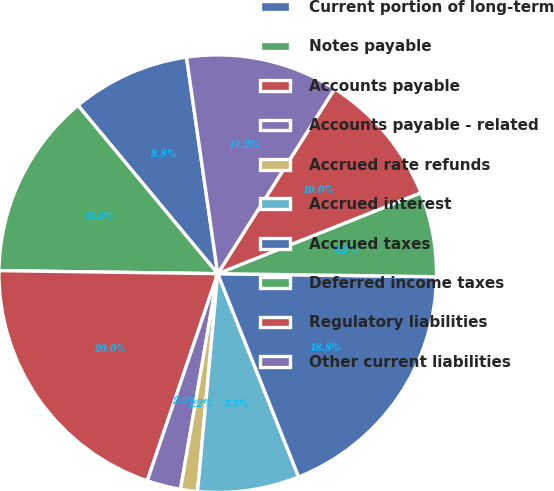Convert chart. <chart><loc_0><loc_0><loc_500><loc_500><pie_chart><fcel>Current portion of long-term<fcel>Notes payable<fcel>Accounts payable<fcel>Accounts payable - related<fcel>Accrued rate refunds<fcel>Accrued interest<fcel>Accrued taxes<fcel>Deferred income taxes<fcel>Regulatory liabilities<fcel>Other current liabilities<nl><fcel>8.75%<fcel>13.75%<fcel>20.0%<fcel>2.5%<fcel>1.25%<fcel>7.5%<fcel>18.75%<fcel>6.25%<fcel>10.0%<fcel>11.25%<nl></chart> 